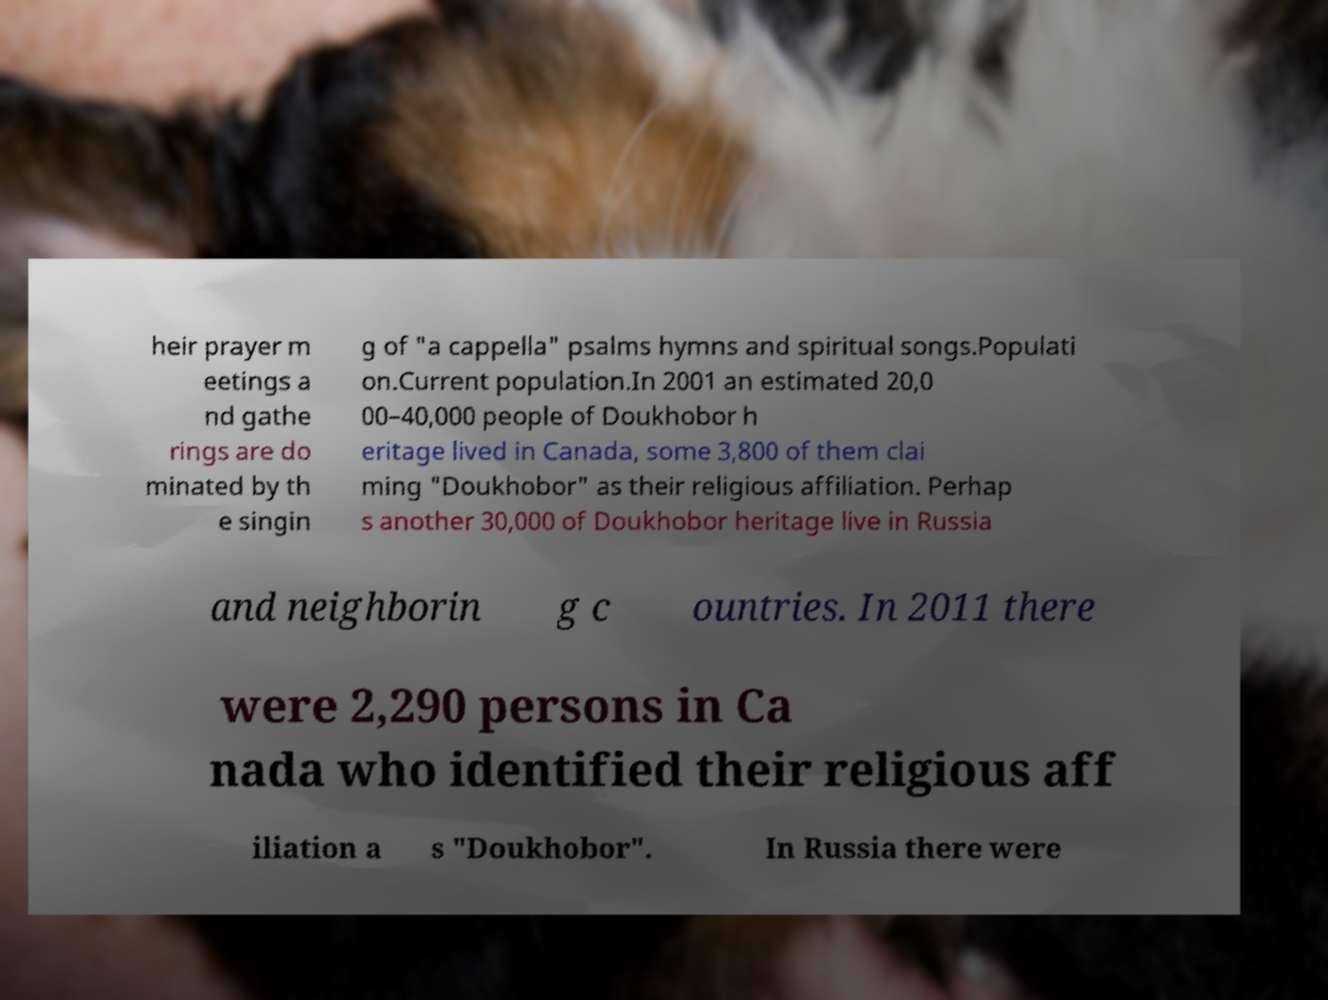For documentation purposes, I need the text within this image transcribed. Could you provide that? heir prayer m eetings a nd gathe rings are do minated by th e singin g of "a cappella" psalms hymns and spiritual songs.Populati on.Current population.In 2001 an estimated 20,0 00–40,000 people of Doukhobor h eritage lived in Canada, some 3,800 of them clai ming "Doukhobor" as their religious affiliation. Perhap s another 30,000 of Doukhobor heritage live in Russia and neighborin g c ountries. In 2011 there were 2,290 persons in Ca nada who identified their religious aff iliation a s "Doukhobor". In Russia there were 